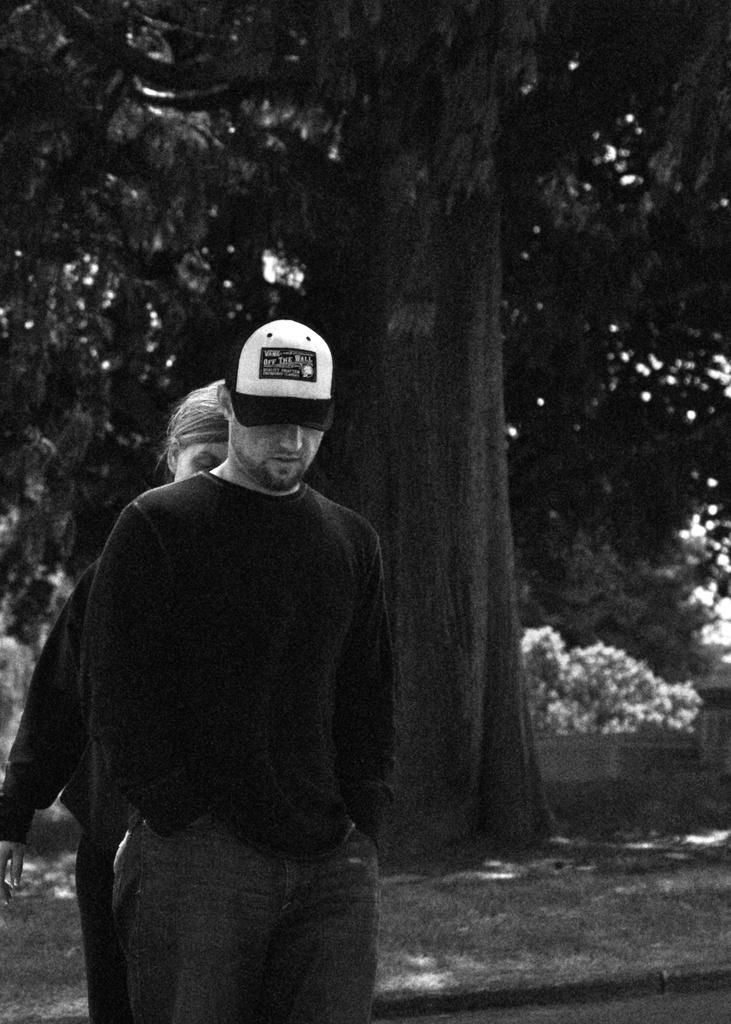How many people are in the image? There are two people in the image. Where are the two people located? The two people are standing on the left side. What is the person in front wearing? The person in front is wearing a car (possibly a t-shirt with a car design). What type of natural element can be seen in the image? There is a tree in the image. What is the name of the person in the image? The provided facts do not mention any names, so we cannot determine the name of the person in the image. What impulse caused the tree to grow in the image? The provided facts do not mention any specific causes for the tree's growth, so we cannot determine the impulse that caused the tree to grow in the image. 